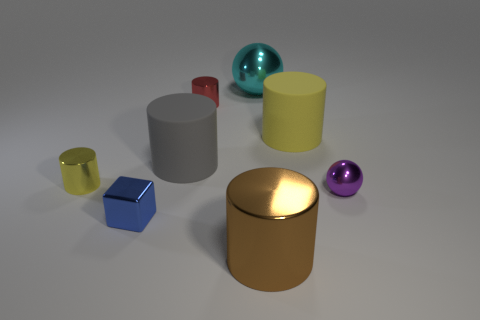What number of yellow cylinders are both on the left side of the cyan metal sphere and on the right side of the tiny blue metal block? In the image, there are two yellow cylinders; however, according to the specified spatial conditions in your question, there are no yellow cylinders that meet the criteria of being both on the left side of the cyan metal sphere and on the right side of the tiny blue metal block. All the yellow cylinders are either on one side or the other, not between these two objects. 